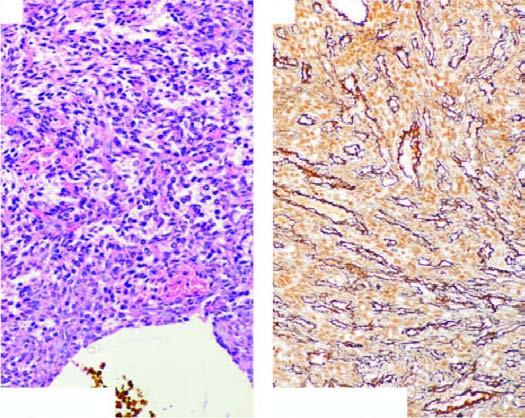do the alveolar capillaries surround the vascular lumina in a whorled fashion, highlighted by reticulin stain?
Answer the question using a single word or phrase. No 